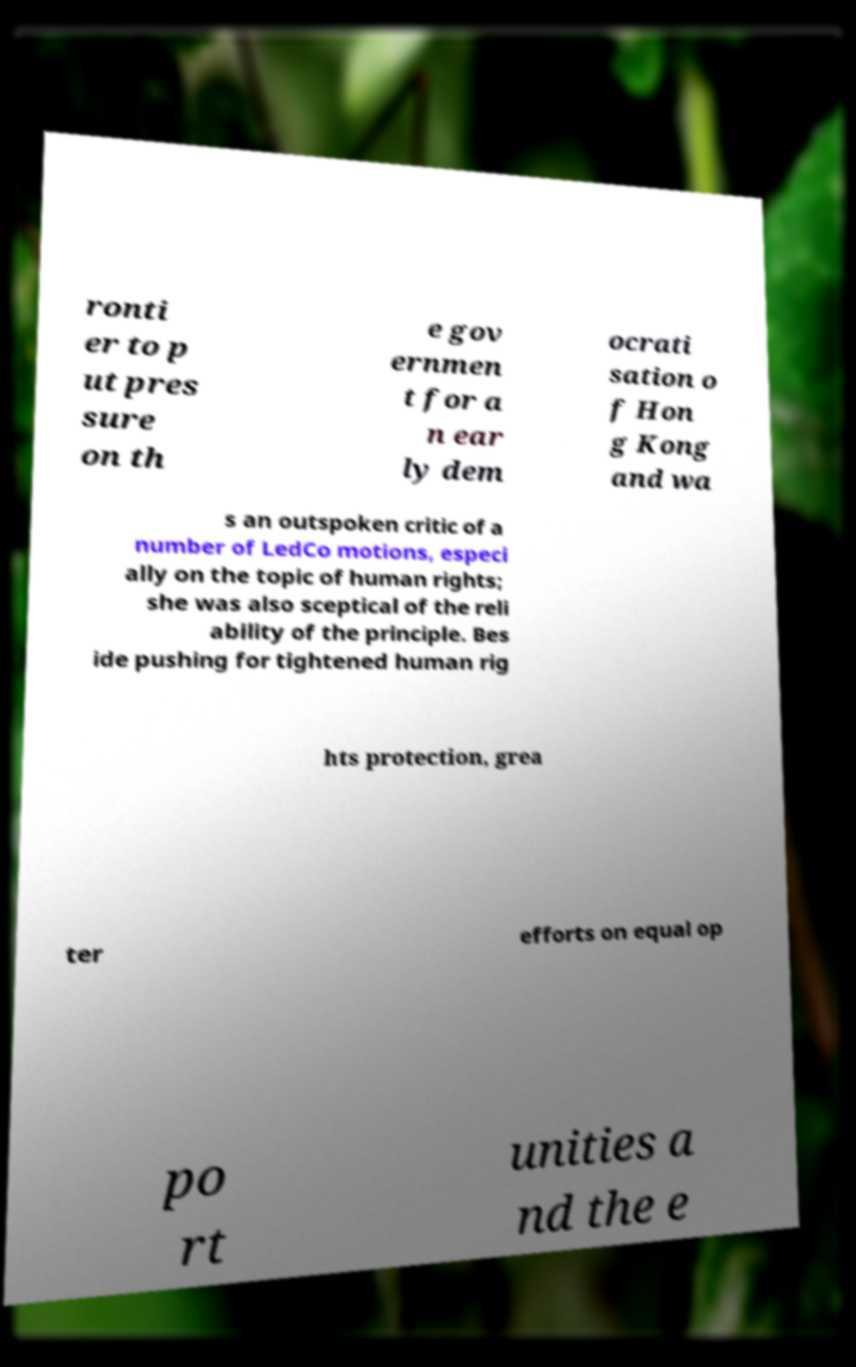There's text embedded in this image that I need extracted. Can you transcribe it verbatim? ronti er to p ut pres sure on th e gov ernmen t for a n ear ly dem ocrati sation o f Hon g Kong and wa s an outspoken critic of a number of LedCo motions, especi ally on the topic of human rights; she was also sceptical of the reli ability of the principle. Bes ide pushing for tightened human rig hts protection, grea ter efforts on equal op po rt unities a nd the e 